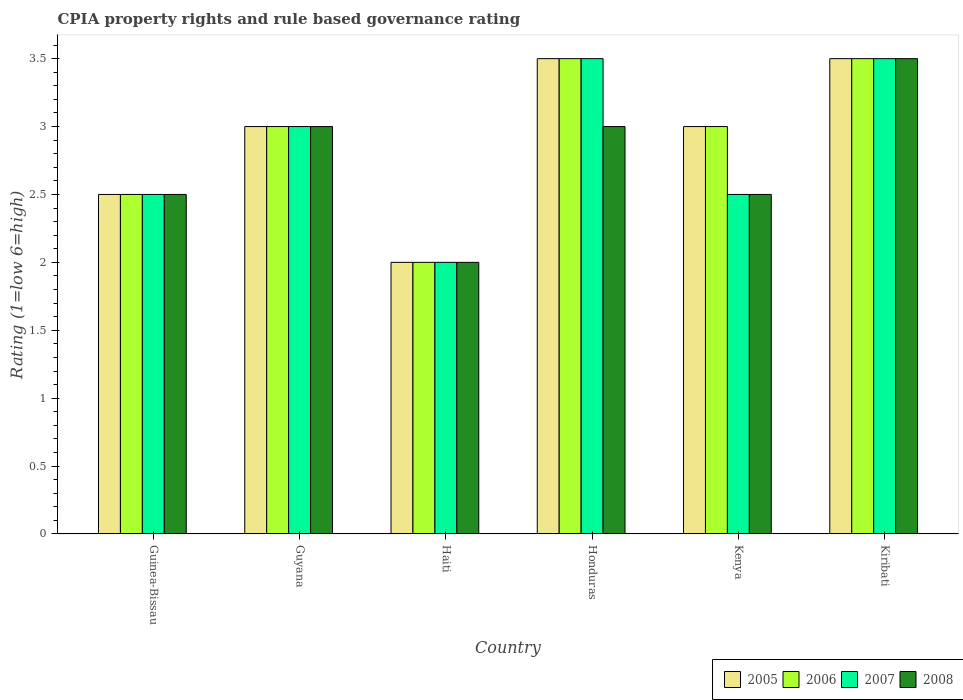How many different coloured bars are there?
Offer a very short reply. 4. How many bars are there on the 6th tick from the right?
Provide a succinct answer. 4. What is the label of the 5th group of bars from the left?
Give a very brief answer. Kenya. In how many cases, is the number of bars for a given country not equal to the number of legend labels?
Your answer should be very brief. 0. What is the CPIA rating in 2008 in Kenya?
Your answer should be very brief. 2.5. Across all countries, what is the maximum CPIA rating in 2008?
Your answer should be compact. 3.5. Across all countries, what is the minimum CPIA rating in 2005?
Offer a terse response. 2. In which country was the CPIA rating in 2006 maximum?
Your response must be concise. Honduras. In which country was the CPIA rating in 2008 minimum?
Your answer should be compact. Haiti. What is the total CPIA rating in 2005 in the graph?
Give a very brief answer. 17.5. What is the difference between the CPIA rating in 2007 in Guyana and that in Kenya?
Offer a terse response. 0.5. What is the difference between the CPIA rating in 2008 in Kenya and the CPIA rating in 2005 in Kiribati?
Give a very brief answer. -1. What is the average CPIA rating in 2007 per country?
Your response must be concise. 2.83. What is the difference between the CPIA rating of/in 2005 and CPIA rating of/in 2008 in Guinea-Bissau?
Keep it short and to the point. 0. In how many countries, is the CPIA rating in 2007 greater than 2.7?
Your response must be concise. 3. What is the ratio of the CPIA rating in 2007 in Guyana to that in Honduras?
Offer a very short reply. 0.86. Is the difference between the CPIA rating in 2005 in Haiti and Kiribati greater than the difference between the CPIA rating in 2008 in Haiti and Kiribati?
Your answer should be compact. No. What is the difference between the highest and the second highest CPIA rating in 2006?
Provide a short and direct response. -0.5. What is the difference between the highest and the lowest CPIA rating in 2005?
Make the answer very short. 1.5. Is the sum of the CPIA rating in 2007 in Guinea-Bissau and Kiribati greater than the maximum CPIA rating in 2006 across all countries?
Offer a very short reply. Yes. Is it the case that in every country, the sum of the CPIA rating in 2007 and CPIA rating in 2008 is greater than the sum of CPIA rating in 2006 and CPIA rating in 2005?
Keep it short and to the point. No. What does the 2nd bar from the left in Haiti represents?
Offer a terse response. 2006. Are all the bars in the graph horizontal?
Keep it short and to the point. No. How many countries are there in the graph?
Offer a terse response. 6. What is the difference between two consecutive major ticks on the Y-axis?
Provide a short and direct response. 0.5. Where does the legend appear in the graph?
Ensure brevity in your answer.  Bottom right. How many legend labels are there?
Your response must be concise. 4. How are the legend labels stacked?
Offer a terse response. Horizontal. What is the title of the graph?
Make the answer very short. CPIA property rights and rule based governance rating. What is the label or title of the X-axis?
Provide a succinct answer. Country. What is the Rating (1=low 6=high) in 2006 in Guinea-Bissau?
Offer a very short reply. 2.5. What is the Rating (1=low 6=high) in 2005 in Haiti?
Offer a terse response. 2. What is the Rating (1=low 6=high) of 2006 in Haiti?
Your answer should be compact. 2. What is the Rating (1=low 6=high) in 2007 in Haiti?
Provide a short and direct response. 2. What is the Rating (1=low 6=high) in 2005 in Honduras?
Provide a short and direct response. 3.5. What is the Rating (1=low 6=high) of 2007 in Honduras?
Offer a terse response. 3.5. What is the Rating (1=low 6=high) in 2008 in Honduras?
Keep it short and to the point. 3. What is the Rating (1=low 6=high) in 2005 in Kenya?
Offer a terse response. 3. What is the Rating (1=low 6=high) of 2006 in Kenya?
Ensure brevity in your answer.  3. What is the Rating (1=low 6=high) in 2007 in Kenya?
Make the answer very short. 2.5. What is the Rating (1=low 6=high) of 2006 in Kiribati?
Keep it short and to the point. 3.5. Across all countries, what is the maximum Rating (1=low 6=high) in 2005?
Make the answer very short. 3.5. Across all countries, what is the maximum Rating (1=low 6=high) in 2006?
Your answer should be very brief. 3.5. Across all countries, what is the maximum Rating (1=low 6=high) of 2007?
Provide a short and direct response. 3.5. Across all countries, what is the minimum Rating (1=low 6=high) of 2006?
Your answer should be very brief. 2. Across all countries, what is the minimum Rating (1=low 6=high) in 2008?
Your answer should be very brief. 2. What is the total Rating (1=low 6=high) of 2007 in the graph?
Your answer should be compact. 17. What is the difference between the Rating (1=low 6=high) of 2006 in Guinea-Bissau and that in Guyana?
Your answer should be very brief. -0.5. What is the difference between the Rating (1=low 6=high) of 2007 in Guinea-Bissau and that in Guyana?
Ensure brevity in your answer.  -0.5. What is the difference between the Rating (1=low 6=high) of 2008 in Guinea-Bissau and that in Guyana?
Make the answer very short. -0.5. What is the difference between the Rating (1=low 6=high) in 2006 in Guinea-Bissau and that in Haiti?
Your answer should be compact. 0.5. What is the difference between the Rating (1=low 6=high) in 2007 in Guinea-Bissau and that in Haiti?
Make the answer very short. 0.5. What is the difference between the Rating (1=low 6=high) of 2005 in Guinea-Bissau and that in Honduras?
Provide a short and direct response. -1. What is the difference between the Rating (1=low 6=high) in 2006 in Guinea-Bissau and that in Honduras?
Your answer should be very brief. -1. What is the difference between the Rating (1=low 6=high) in 2008 in Guinea-Bissau and that in Honduras?
Provide a succinct answer. -0.5. What is the difference between the Rating (1=low 6=high) of 2008 in Guinea-Bissau and that in Kenya?
Ensure brevity in your answer.  0. What is the difference between the Rating (1=low 6=high) in 2008 in Guinea-Bissau and that in Kiribati?
Provide a short and direct response. -1. What is the difference between the Rating (1=low 6=high) in 2005 in Guyana and that in Haiti?
Keep it short and to the point. 1. What is the difference between the Rating (1=low 6=high) of 2008 in Guyana and that in Haiti?
Your response must be concise. 1. What is the difference between the Rating (1=low 6=high) of 2006 in Guyana and that in Honduras?
Make the answer very short. -0.5. What is the difference between the Rating (1=low 6=high) of 2007 in Guyana and that in Honduras?
Provide a succinct answer. -0.5. What is the difference between the Rating (1=low 6=high) of 2008 in Guyana and that in Honduras?
Provide a succinct answer. 0. What is the difference between the Rating (1=low 6=high) in 2008 in Guyana and that in Kenya?
Keep it short and to the point. 0.5. What is the difference between the Rating (1=low 6=high) in 2006 in Haiti and that in Honduras?
Your answer should be compact. -1.5. What is the difference between the Rating (1=low 6=high) of 2005 in Haiti and that in Kenya?
Ensure brevity in your answer.  -1. What is the difference between the Rating (1=low 6=high) in 2006 in Haiti and that in Kiribati?
Ensure brevity in your answer.  -1.5. What is the difference between the Rating (1=low 6=high) in 2008 in Haiti and that in Kiribati?
Offer a terse response. -1.5. What is the difference between the Rating (1=low 6=high) of 2005 in Honduras and that in Kenya?
Your answer should be very brief. 0.5. What is the difference between the Rating (1=low 6=high) in 2007 in Honduras and that in Kiribati?
Make the answer very short. 0. What is the difference between the Rating (1=low 6=high) of 2007 in Kenya and that in Kiribati?
Keep it short and to the point. -1. What is the difference between the Rating (1=low 6=high) of 2008 in Kenya and that in Kiribati?
Your answer should be very brief. -1. What is the difference between the Rating (1=low 6=high) of 2005 in Guinea-Bissau and the Rating (1=low 6=high) of 2006 in Guyana?
Offer a terse response. -0.5. What is the difference between the Rating (1=low 6=high) in 2005 in Guinea-Bissau and the Rating (1=low 6=high) in 2007 in Guyana?
Your response must be concise. -0.5. What is the difference between the Rating (1=low 6=high) in 2006 in Guinea-Bissau and the Rating (1=low 6=high) in 2008 in Guyana?
Keep it short and to the point. -0.5. What is the difference between the Rating (1=low 6=high) in 2005 in Guinea-Bissau and the Rating (1=low 6=high) in 2007 in Haiti?
Keep it short and to the point. 0.5. What is the difference between the Rating (1=low 6=high) of 2006 in Guinea-Bissau and the Rating (1=low 6=high) of 2007 in Haiti?
Offer a terse response. 0.5. What is the difference between the Rating (1=low 6=high) in 2006 in Guinea-Bissau and the Rating (1=low 6=high) in 2008 in Haiti?
Your answer should be very brief. 0.5. What is the difference between the Rating (1=low 6=high) of 2007 in Guinea-Bissau and the Rating (1=low 6=high) of 2008 in Haiti?
Offer a terse response. 0.5. What is the difference between the Rating (1=low 6=high) of 2005 in Guinea-Bissau and the Rating (1=low 6=high) of 2008 in Honduras?
Give a very brief answer. -0.5. What is the difference between the Rating (1=low 6=high) in 2006 in Guinea-Bissau and the Rating (1=low 6=high) in 2007 in Honduras?
Keep it short and to the point. -1. What is the difference between the Rating (1=low 6=high) of 2006 in Guinea-Bissau and the Rating (1=low 6=high) of 2008 in Honduras?
Your answer should be very brief. -0.5. What is the difference between the Rating (1=low 6=high) of 2005 in Guinea-Bissau and the Rating (1=low 6=high) of 2007 in Kenya?
Provide a succinct answer. 0. What is the difference between the Rating (1=low 6=high) in 2006 in Guinea-Bissau and the Rating (1=low 6=high) in 2008 in Kenya?
Offer a very short reply. 0. What is the difference between the Rating (1=low 6=high) in 2005 in Guinea-Bissau and the Rating (1=low 6=high) in 2006 in Kiribati?
Your answer should be very brief. -1. What is the difference between the Rating (1=low 6=high) in 2005 in Guinea-Bissau and the Rating (1=low 6=high) in 2007 in Kiribati?
Your response must be concise. -1. What is the difference between the Rating (1=low 6=high) in 2006 in Guinea-Bissau and the Rating (1=low 6=high) in 2008 in Kiribati?
Your answer should be very brief. -1. What is the difference between the Rating (1=low 6=high) of 2005 in Guyana and the Rating (1=low 6=high) of 2006 in Haiti?
Make the answer very short. 1. What is the difference between the Rating (1=low 6=high) in 2005 in Guyana and the Rating (1=low 6=high) in 2007 in Haiti?
Give a very brief answer. 1. What is the difference between the Rating (1=low 6=high) of 2005 in Guyana and the Rating (1=low 6=high) of 2008 in Haiti?
Keep it short and to the point. 1. What is the difference between the Rating (1=low 6=high) in 2006 in Guyana and the Rating (1=low 6=high) in 2007 in Haiti?
Your answer should be compact. 1. What is the difference between the Rating (1=low 6=high) of 2006 in Guyana and the Rating (1=low 6=high) of 2008 in Haiti?
Ensure brevity in your answer.  1. What is the difference between the Rating (1=low 6=high) of 2007 in Guyana and the Rating (1=low 6=high) of 2008 in Haiti?
Your response must be concise. 1. What is the difference between the Rating (1=low 6=high) of 2005 in Guyana and the Rating (1=low 6=high) of 2008 in Honduras?
Keep it short and to the point. 0. What is the difference between the Rating (1=low 6=high) in 2006 in Guyana and the Rating (1=low 6=high) in 2007 in Honduras?
Your answer should be compact. -0.5. What is the difference between the Rating (1=low 6=high) of 2006 in Guyana and the Rating (1=low 6=high) of 2008 in Honduras?
Offer a very short reply. 0. What is the difference between the Rating (1=low 6=high) in 2005 in Guyana and the Rating (1=low 6=high) in 2006 in Kenya?
Keep it short and to the point. 0. What is the difference between the Rating (1=low 6=high) of 2005 in Guyana and the Rating (1=low 6=high) of 2008 in Kenya?
Your answer should be very brief. 0.5. What is the difference between the Rating (1=low 6=high) in 2006 in Guyana and the Rating (1=low 6=high) in 2008 in Kiribati?
Ensure brevity in your answer.  -0.5. What is the difference between the Rating (1=low 6=high) in 2007 in Guyana and the Rating (1=low 6=high) in 2008 in Kiribati?
Offer a terse response. -0.5. What is the difference between the Rating (1=low 6=high) in 2005 in Haiti and the Rating (1=low 6=high) in 2008 in Honduras?
Offer a very short reply. -1. What is the difference between the Rating (1=low 6=high) in 2006 in Haiti and the Rating (1=low 6=high) in 2007 in Honduras?
Provide a succinct answer. -1.5. What is the difference between the Rating (1=low 6=high) of 2006 in Haiti and the Rating (1=low 6=high) of 2008 in Honduras?
Provide a succinct answer. -1. What is the difference between the Rating (1=low 6=high) of 2007 in Haiti and the Rating (1=low 6=high) of 2008 in Honduras?
Ensure brevity in your answer.  -1. What is the difference between the Rating (1=low 6=high) of 2005 in Haiti and the Rating (1=low 6=high) of 2006 in Kenya?
Your response must be concise. -1. What is the difference between the Rating (1=low 6=high) in 2006 in Haiti and the Rating (1=low 6=high) in 2007 in Kenya?
Your answer should be very brief. -0.5. What is the difference between the Rating (1=low 6=high) in 2007 in Haiti and the Rating (1=low 6=high) in 2008 in Kenya?
Your answer should be compact. -0.5. What is the difference between the Rating (1=low 6=high) of 2005 in Haiti and the Rating (1=low 6=high) of 2006 in Kiribati?
Ensure brevity in your answer.  -1.5. What is the difference between the Rating (1=low 6=high) of 2005 in Haiti and the Rating (1=low 6=high) of 2007 in Kiribati?
Your response must be concise. -1.5. What is the difference between the Rating (1=low 6=high) in 2005 in Haiti and the Rating (1=low 6=high) in 2008 in Kiribati?
Ensure brevity in your answer.  -1.5. What is the difference between the Rating (1=low 6=high) in 2006 in Haiti and the Rating (1=low 6=high) in 2007 in Kiribati?
Provide a succinct answer. -1.5. What is the difference between the Rating (1=low 6=high) in 2005 in Honduras and the Rating (1=low 6=high) in 2006 in Kenya?
Your answer should be very brief. 0.5. What is the difference between the Rating (1=low 6=high) of 2006 in Honduras and the Rating (1=low 6=high) of 2007 in Kenya?
Offer a terse response. 1. What is the difference between the Rating (1=low 6=high) of 2007 in Honduras and the Rating (1=low 6=high) of 2008 in Kenya?
Your answer should be compact. 1. What is the difference between the Rating (1=low 6=high) in 2005 in Honduras and the Rating (1=low 6=high) in 2006 in Kiribati?
Offer a terse response. 0. What is the difference between the Rating (1=low 6=high) of 2006 in Honduras and the Rating (1=low 6=high) of 2008 in Kiribati?
Your answer should be very brief. 0. What is the difference between the Rating (1=low 6=high) in 2007 in Honduras and the Rating (1=low 6=high) in 2008 in Kiribati?
Your answer should be very brief. 0. What is the difference between the Rating (1=low 6=high) of 2005 in Kenya and the Rating (1=low 6=high) of 2006 in Kiribati?
Provide a short and direct response. -0.5. What is the difference between the Rating (1=low 6=high) in 2006 in Kenya and the Rating (1=low 6=high) in 2007 in Kiribati?
Keep it short and to the point. -0.5. What is the difference between the Rating (1=low 6=high) of 2007 in Kenya and the Rating (1=low 6=high) of 2008 in Kiribati?
Offer a very short reply. -1. What is the average Rating (1=low 6=high) in 2005 per country?
Offer a terse response. 2.92. What is the average Rating (1=low 6=high) in 2006 per country?
Ensure brevity in your answer.  2.92. What is the average Rating (1=low 6=high) in 2007 per country?
Keep it short and to the point. 2.83. What is the average Rating (1=low 6=high) in 2008 per country?
Your response must be concise. 2.75. What is the difference between the Rating (1=low 6=high) of 2005 and Rating (1=low 6=high) of 2006 in Guinea-Bissau?
Give a very brief answer. 0. What is the difference between the Rating (1=low 6=high) in 2005 and Rating (1=low 6=high) in 2008 in Guinea-Bissau?
Offer a very short reply. 0. What is the difference between the Rating (1=low 6=high) of 2006 and Rating (1=low 6=high) of 2007 in Guinea-Bissau?
Offer a terse response. 0. What is the difference between the Rating (1=low 6=high) of 2005 and Rating (1=low 6=high) of 2006 in Guyana?
Your answer should be very brief. 0. What is the difference between the Rating (1=low 6=high) of 2005 and Rating (1=low 6=high) of 2007 in Guyana?
Provide a succinct answer. 0. What is the difference between the Rating (1=low 6=high) of 2006 and Rating (1=low 6=high) of 2008 in Guyana?
Your answer should be very brief. 0. What is the difference between the Rating (1=low 6=high) in 2007 and Rating (1=low 6=high) in 2008 in Guyana?
Provide a short and direct response. 0. What is the difference between the Rating (1=low 6=high) of 2005 and Rating (1=low 6=high) of 2006 in Haiti?
Keep it short and to the point. 0. What is the difference between the Rating (1=low 6=high) in 2005 and Rating (1=low 6=high) in 2007 in Haiti?
Provide a succinct answer. 0. What is the difference between the Rating (1=low 6=high) in 2006 and Rating (1=low 6=high) in 2008 in Haiti?
Offer a terse response. 0. What is the difference between the Rating (1=low 6=high) of 2007 and Rating (1=low 6=high) of 2008 in Haiti?
Make the answer very short. 0. What is the difference between the Rating (1=low 6=high) in 2005 and Rating (1=low 6=high) in 2006 in Honduras?
Your answer should be very brief. 0. What is the difference between the Rating (1=low 6=high) in 2005 and Rating (1=low 6=high) in 2007 in Honduras?
Make the answer very short. 0. What is the difference between the Rating (1=low 6=high) of 2006 and Rating (1=low 6=high) of 2007 in Honduras?
Keep it short and to the point. 0. What is the difference between the Rating (1=low 6=high) of 2007 and Rating (1=low 6=high) of 2008 in Honduras?
Provide a succinct answer. 0.5. What is the difference between the Rating (1=low 6=high) of 2005 and Rating (1=low 6=high) of 2007 in Kenya?
Provide a succinct answer. 0.5. What is the difference between the Rating (1=low 6=high) of 2006 and Rating (1=low 6=high) of 2007 in Kenya?
Give a very brief answer. 0.5. What is the difference between the Rating (1=low 6=high) in 2005 and Rating (1=low 6=high) in 2006 in Kiribati?
Make the answer very short. 0. What is the difference between the Rating (1=low 6=high) of 2005 and Rating (1=low 6=high) of 2007 in Kiribati?
Your response must be concise. 0. What is the difference between the Rating (1=low 6=high) in 2005 and Rating (1=low 6=high) in 2008 in Kiribati?
Give a very brief answer. 0. What is the difference between the Rating (1=low 6=high) of 2006 and Rating (1=low 6=high) of 2007 in Kiribati?
Offer a terse response. 0. What is the difference between the Rating (1=low 6=high) of 2006 and Rating (1=low 6=high) of 2008 in Kiribati?
Your answer should be very brief. 0. What is the ratio of the Rating (1=low 6=high) of 2008 in Guinea-Bissau to that in Guyana?
Make the answer very short. 0.83. What is the ratio of the Rating (1=low 6=high) of 2005 in Guinea-Bissau to that in Haiti?
Your response must be concise. 1.25. What is the ratio of the Rating (1=low 6=high) in 2008 in Guinea-Bissau to that in Haiti?
Keep it short and to the point. 1.25. What is the ratio of the Rating (1=low 6=high) in 2005 in Guinea-Bissau to that in Honduras?
Keep it short and to the point. 0.71. What is the ratio of the Rating (1=low 6=high) of 2007 in Guinea-Bissau to that in Honduras?
Give a very brief answer. 0.71. What is the ratio of the Rating (1=low 6=high) in 2005 in Guinea-Bissau to that in Kenya?
Ensure brevity in your answer.  0.83. What is the ratio of the Rating (1=low 6=high) in 2007 in Guinea-Bissau to that in Kenya?
Your answer should be very brief. 1. What is the ratio of the Rating (1=low 6=high) in 2005 in Guinea-Bissau to that in Kiribati?
Your answer should be very brief. 0.71. What is the ratio of the Rating (1=low 6=high) in 2008 in Guyana to that in Haiti?
Give a very brief answer. 1.5. What is the ratio of the Rating (1=low 6=high) in 2005 in Guyana to that in Honduras?
Make the answer very short. 0.86. What is the ratio of the Rating (1=low 6=high) in 2006 in Guyana to that in Kenya?
Ensure brevity in your answer.  1. What is the ratio of the Rating (1=low 6=high) of 2008 in Guyana to that in Kenya?
Make the answer very short. 1.2. What is the ratio of the Rating (1=low 6=high) in 2005 in Guyana to that in Kiribati?
Offer a terse response. 0.86. What is the ratio of the Rating (1=low 6=high) of 2006 in Guyana to that in Kiribati?
Ensure brevity in your answer.  0.86. What is the ratio of the Rating (1=low 6=high) of 2007 in Guyana to that in Kiribati?
Keep it short and to the point. 0.86. What is the ratio of the Rating (1=low 6=high) in 2005 in Haiti to that in Honduras?
Provide a short and direct response. 0.57. What is the ratio of the Rating (1=low 6=high) in 2008 in Haiti to that in Honduras?
Ensure brevity in your answer.  0.67. What is the ratio of the Rating (1=low 6=high) of 2005 in Haiti to that in Kenya?
Your answer should be very brief. 0.67. What is the ratio of the Rating (1=low 6=high) in 2006 in Haiti to that in Kenya?
Provide a succinct answer. 0.67. What is the ratio of the Rating (1=low 6=high) in 2007 in Haiti to that in Kenya?
Your response must be concise. 0.8. What is the ratio of the Rating (1=low 6=high) in 2008 in Haiti to that in Kenya?
Your response must be concise. 0.8. What is the ratio of the Rating (1=low 6=high) in 2007 in Haiti to that in Kiribati?
Provide a succinct answer. 0.57. What is the ratio of the Rating (1=low 6=high) of 2005 in Honduras to that in Kiribati?
Provide a short and direct response. 1. What is the ratio of the Rating (1=low 6=high) in 2006 in Honduras to that in Kiribati?
Your response must be concise. 1. What is the ratio of the Rating (1=low 6=high) of 2007 in Honduras to that in Kiribati?
Give a very brief answer. 1. What is the ratio of the Rating (1=low 6=high) of 2008 in Kenya to that in Kiribati?
Offer a very short reply. 0.71. What is the difference between the highest and the second highest Rating (1=low 6=high) of 2008?
Offer a very short reply. 0.5. What is the difference between the highest and the lowest Rating (1=low 6=high) of 2006?
Your answer should be very brief. 1.5. What is the difference between the highest and the lowest Rating (1=low 6=high) of 2007?
Your answer should be very brief. 1.5. 